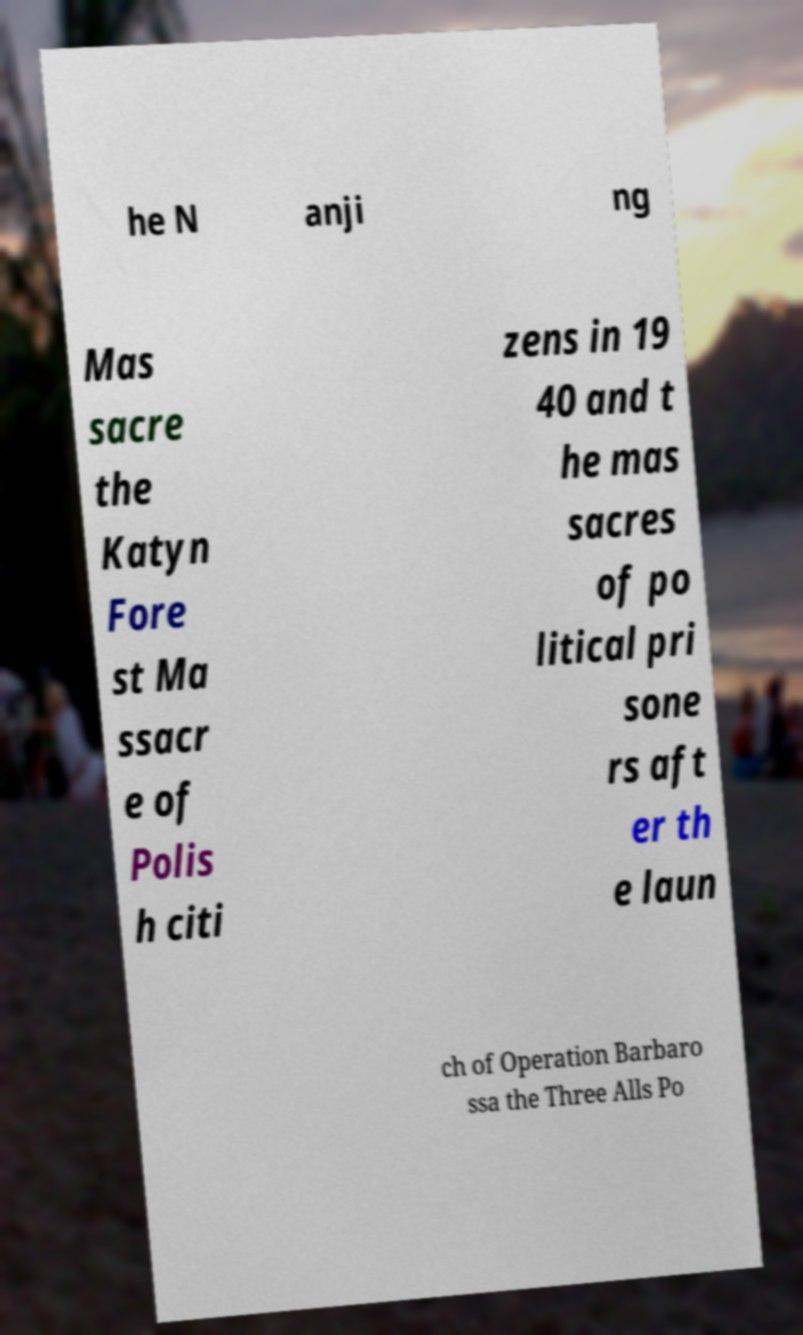Can you accurately transcribe the text from the provided image for me? he N anji ng Mas sacre the Katyn Fore st Ma ssacr e of Polis h citi zens in 19 40 and t he mas sacres of po litical pri sone rs aft er th e laun ch of Operation Barbaro ssa the Three Alls Po 